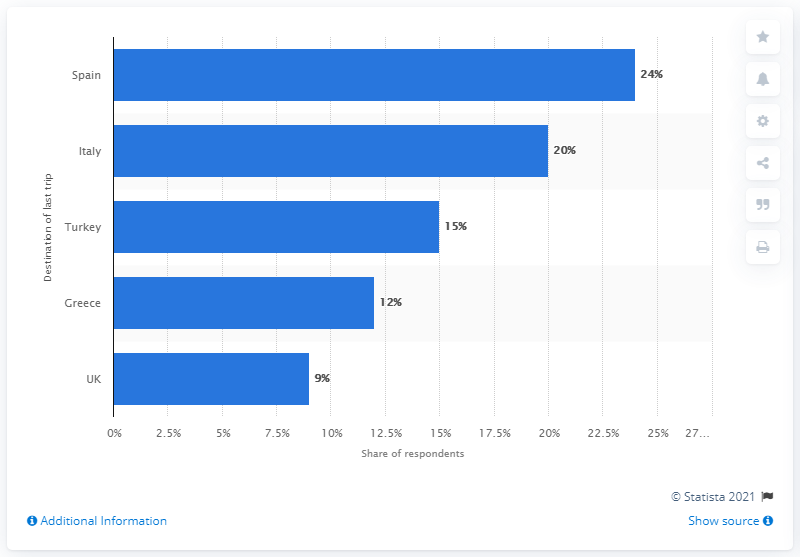Indicate a few pertinent items in this graphic. Spain is the most popular intra-European destination. 